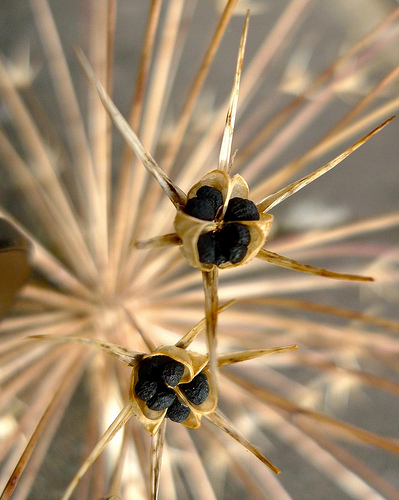<image>
Can you confirm if the burr is above the flower? Yes. The burr is positioned above the flower in the vertical space, higher up in the scene. 